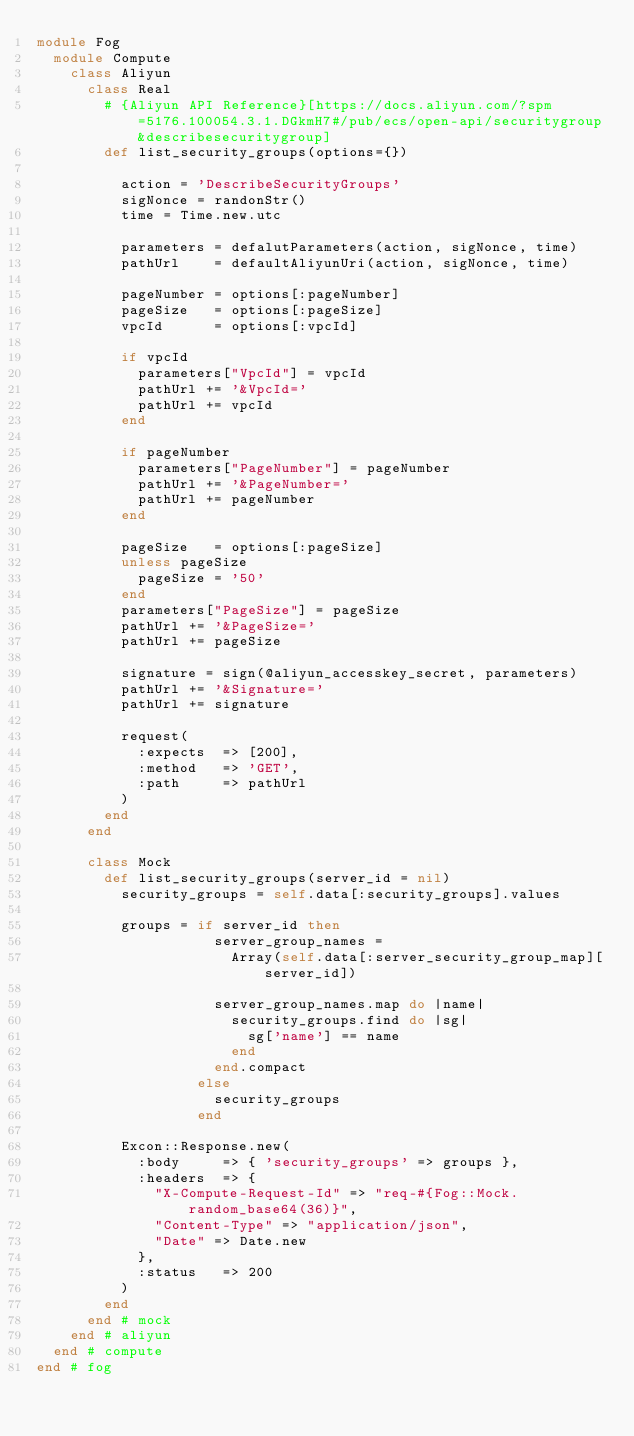Convert code to text. <code><loc_0><loc_0><loc_500><loc_500><_Ruby_>module Fog
  module Compute
    class Aliyun
      class Real
        # {Aliyun API Reference}[https://docs.aliyun.com/?spm=5176.100054.3.1.DGkmH7#/pub/ecs/open-api/securitygroup&describesecuritygroup]
        def list_security_groups(options={})

          action = 'DescribeSecurityGroups'
          sigNonce = randonStr()
          time = Time.new.utc

          parameters = defalutParameters(action, sigNonce, time)
          pathUrl    = defaultAliyunUri(action, sigNonce, time)

          pageNumber = options[:pageNumber]
          pageSize   = options[:pageSize]
          vpcId      = options[:vpcId]
          
          if vpcId
            parameters["VpcId"] = vpcId
            pathUrl += '&VpcId='
            pathUrl += vpcId
          end

          if pageNumber
            parameters["PageNumber"] = pageNumber
            pathUrl += '&PageNumber='
            pathUrl += pageNumber
          end

          pageSize   = options[:pageSize]
          unless pageSize
            pageSize = '50'
          end
          parameters["PageSize"] = pageSize  
          pathUrl += '&PageSize='
          pathUrl += pageSize	

          signature = sign(@aliyun_accesskey_secret, parameters)
          pathUrl += '&Signature='
          pathUrl += signature

          request(
            :expects  => [200],
            :method   => 'GET',
            :path     => pathUrl
          )
        end
      end

      class Mock
        def list_security_groups(server_id = nil)
          security_groups = self.data[:security_groups].values

          groups = if server_id then
                     server_group_names =
                       Array(self.data[:server_security_group_map][server_id])

                     server_group_names.map do |name|
                       security_groups.find do |sg|
                         sg['name'] == name
                       end
                     end.compact
                   else
                     security_groups
                   end

          Excon::Response.new(
            :body     => { 'security_groups' => groups },
            :headers  => {
              "X-Compute-Request-Id" => "req-#{Fog::Mock.random_base64(36)}",
              "Content-Type" => "application/json",
              "Date" => Date.new
            },
            :status   => 200
          )
        end
      end # mock
    end # aliyun
  end # compute
end # fog
</code> 